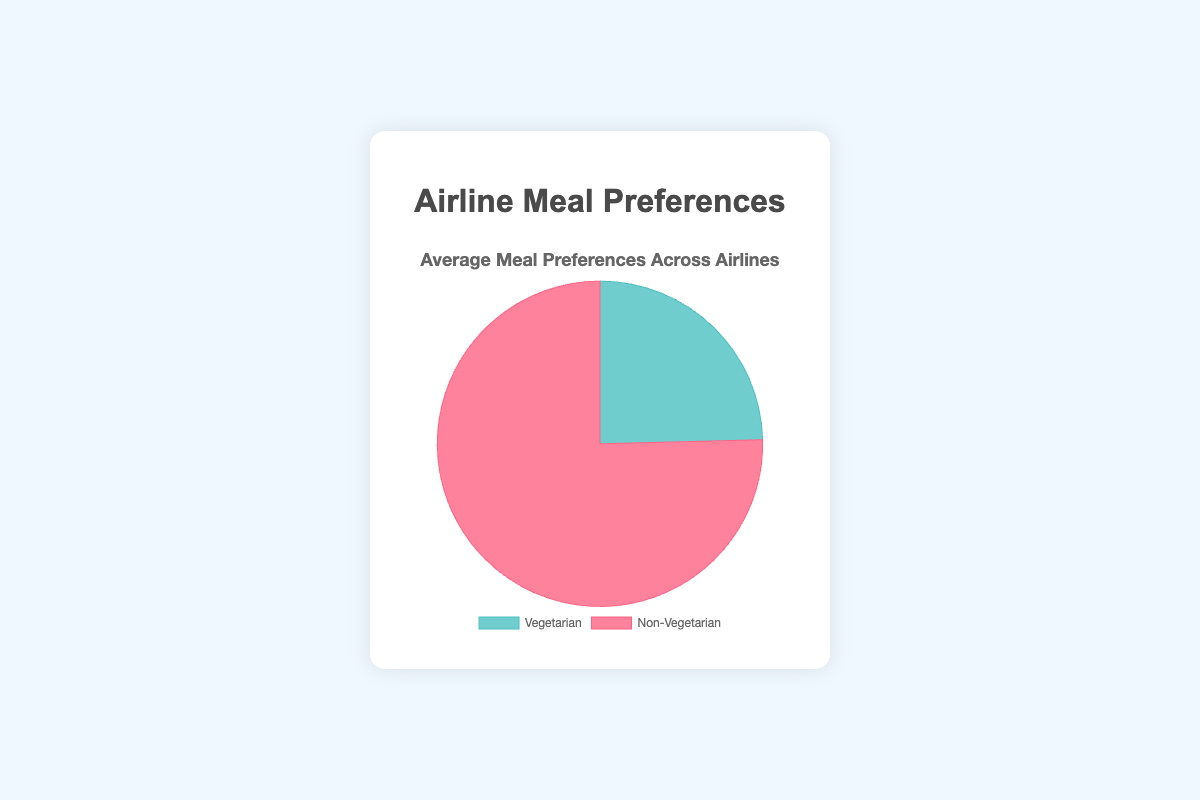Which meal preference is more popular among airline passengers? The pie chart shows two segments: one representing Vegetarian meal requests and the other representing Non-Vegetarian meal requests. The segment representing Non-Vegetarian meal requests is visually larger.
Answer: Non-Vegetarian What percentage of meal requests are for Vegetarian meals? The pie chart includes data for two types of meal requests. The segment for Vegetarian meals is labeled with its percentage, which is 24.6%.
Answer: 24.6% How much higher is the percentage of Non-Vegetarian meal requests compared to Vegetarian meal requests? The chart shows that Vegetarian meal requests make up 24.6%, and Non-Vegetarian meal requests make up 75.4%. To find the difference, subtract 24.6% from 75.4%.
Answer: 50.8% If there were 1,000 meal requests, how many of them would be for Vegetarian meals? If 24.6% of the meal requests are Vegetarian and the total number of meal requests is 1,000, multiply 1000 by 24.6% (0.246).
Answer: 246 What is the average percentage of Vegetarian meal requests across all airlines? The segment for Vegetarian meal requests shows an average percentage of 24.6%. This value represents the average across all specified airlines.
Answer: 24.6% How do the proportions of Vegetarian and Non-Vegetarian meal requests compare visually in the pie chart? The chart uses different colors to display the segments for Vegetarian and Non-Vegetarian meal requests. The Non-Vegetarian segment is larger and occupies a bigger portion of the pie chart.
Answer: The Non-Vegetarian segment is larger Which color represents the Vegetarian meal requests in the pie chart? In the pie chart, the Vegetarian segment is shown in green, whereas the Non-Vegetarian segment is shown in red.
Answer: Green What is the sum of the percentages of Vegetarian and Non-Vegetarian meal requests? The percentages for Vegetarian and Non-Vegetarian meal requests add up to the total percentage, which should be 100%. So, 24.6% + 75.4% equals 100%.
Answer: 100% If the percentage of Vegetarian meal requests at Delta Airlines increases to 30%, how would that affect the overall average percentage? The new percentage for Delta Airlines would be 30%. Recalculate the average percentage with the new data: [(25 + 30 + 30 + 18 + 22) / 5].
Answer: 25% How diverse are the meal preferences across different airlines? By examining the varying percentages of meal requests per airline in the data provided, it's clear there is significant variation. For example, United Airlines has the highest percentage of Vegetarian requests (30%), while Southwest Airlines has the lowest (18%).
Answer: Significant variation 